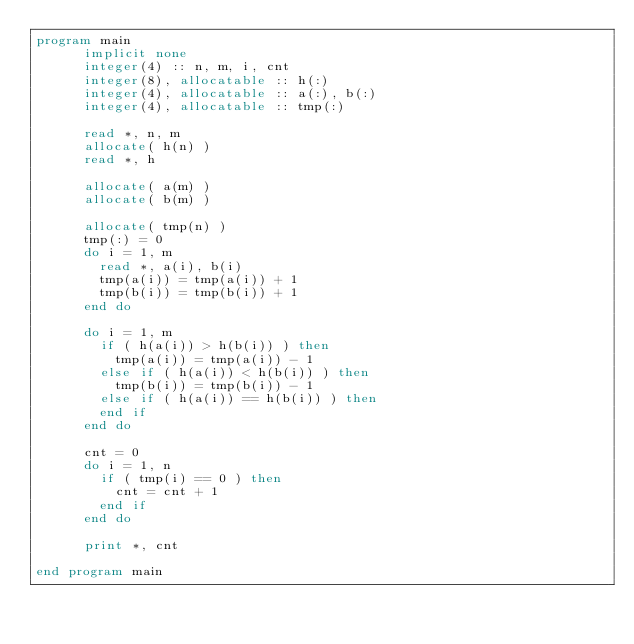<code> <loc_0><loc_0><loc_500><loc_500><_FORTRAN_>program main
      implicit none
      integer(4) :: n, m, i, cnt
      integer(8), allocatable :: h(:)
      integer(4), allocatable :: a(:), b(:)
      integer(4), allocatable :: tmp(:)

      read *, n, m
      allocate( h(n) )
      read *, h

      allocate( a(m) )
      allocate( b(m) )

      allocate( tmp(n) )
      tmp(:) = 0
      do i = 1, m
        read *, a(i), b(i)
        tmp(a(i)) = tmp(a(i)) + 1
        tmp(b(i)) = tmp(b(i)) + 1
      end do

      do i = 1, m
        if ( h(a(i)) > h(b(i)) ) then
          tmp(a(i)) = tmp(a(i)) - 1
        else if ( h(a(i)) < h(b(i)) ) then
          tmp(b(i)) = tmp(b(i)) - 1
        else if ( h(a(i)) == h(b(i)) ) then
        end if
      end do

      cnt = 0
      do i = 1, n
        if ( tmp(i) == 0 ) then
          cnt = cnt + 1
        end if
      end do

      print *, cnt

end program main
</code> 